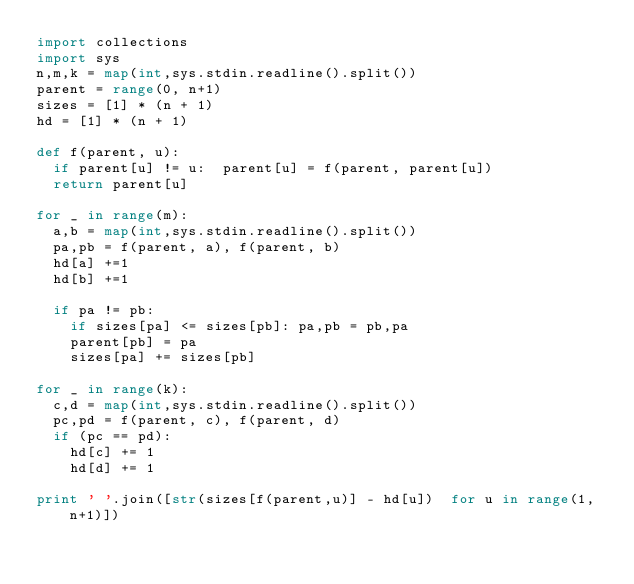<code> <loc_0><loc_0><loc_500><loc_500><_Python_>import collections
import sys
n,m,k = map(int,sys.stdin.readline().split())
parent = range(0, n+1)
sizes = [1] * (n + 1)
hd = [1] * (n + 1) 

def f(parent, u):
	if parent[u] != u:  parent[u] = f(parent, parent[u])
	return parent[u]

for _ in range(m):
	a,b = map(int,sys.stdin.readline().split())
	pa,pb = f(parent, a), f(parent, b)
	hd[a] +=1
	hd[b] +=1

	if pa != pb:
		if sizes[pa] <= sizes[pb]: pa,pb = pb,pa
		parent[pb] = pa
		sizes[pa] += sizes[pb]
		
for _ in range(k):
	c,d = map(int,sys.stdin.readline().split())
	pc,pd = f(parent, c), f(parent, d)
	if (pc == pd):
		hd[c] += 1
		hd[d] += 1

print ' '.join([str(sizes[f(parent,u)] - hd[u])  for u in range(1, n+1)])</code> 